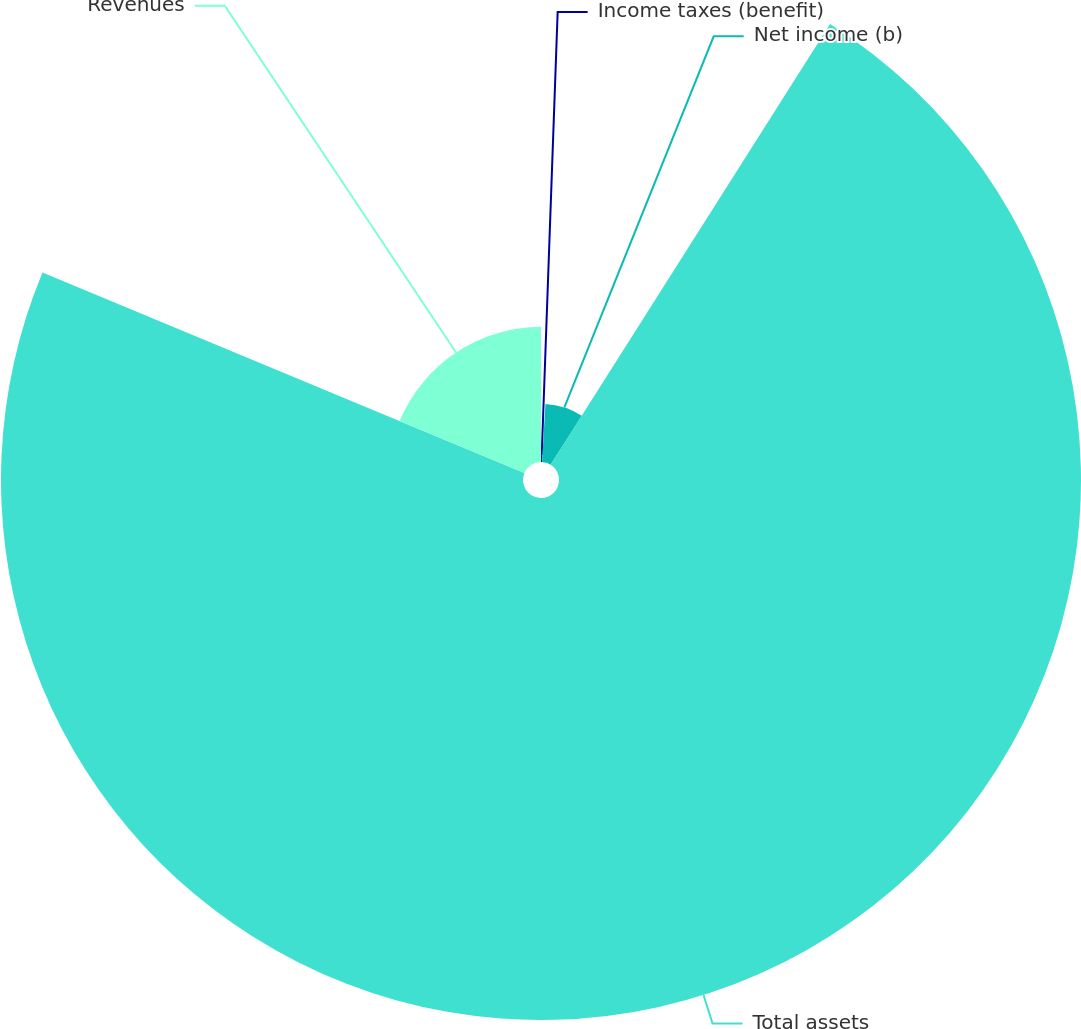<chart> <loc_0><loc_0><loc_500><loc_500><pie_chart><fcel>Income taxes (benefit)<fcel>Net income (b)<fcel>Total assets<fcel>Revenues<nl><fcel>0.93%<fcel>8.06%<fcel>72.29%<fcel>18.72%<nl></chart> 